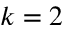Convert formula to latex. <formula><loc_0><loc_0><loc_500><loc_500>k = 2</formula> 